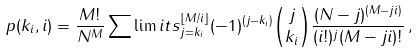<formula> <loc_0><loc_0><loc_500><loc_500>p ( k _ { i } , i ) = \frac { M ! } { N ^ { M } } \sum \lim i t s _ { j = k _ { i } } ^ { \lfloor M / i \rfloor } ( - 1 ) ^ { ( j - k _ { i } ) } \binom { j } { k _ { i } } \frac { ( N - j ) ^ { ( M - j i ) } } { ( i ! ) ^ { j } ( M - j i ) ! } \, ,</formula> 